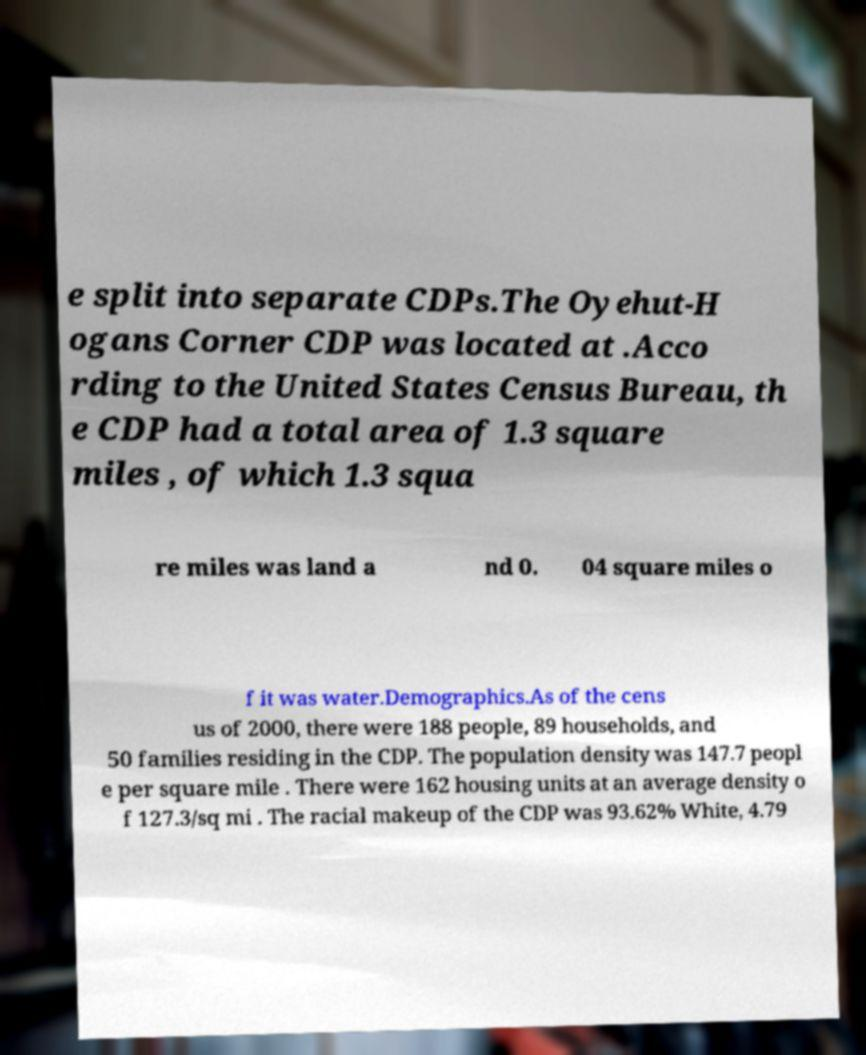Please identify and transcribe the text found in this image. e split into separate CDPs.The Oyehut-H ogans Corner CDP was located at .Acco rding to the United States Census Bureau, th e CDP had a total area of 1.3 square miles , of which 1.3 squa re miles was land a nd 0. 04 square miles o f it was water.Demographics.As of the cens us of 2000, there were 188 people, 89 households, and 50 families residing in the CDP. The population density was 147.7 peopl e per square mile . There were 162 housing units at an average density o f 127.3/sq mi . The racial makeup of the CDP was 93.62% White, 4.79 